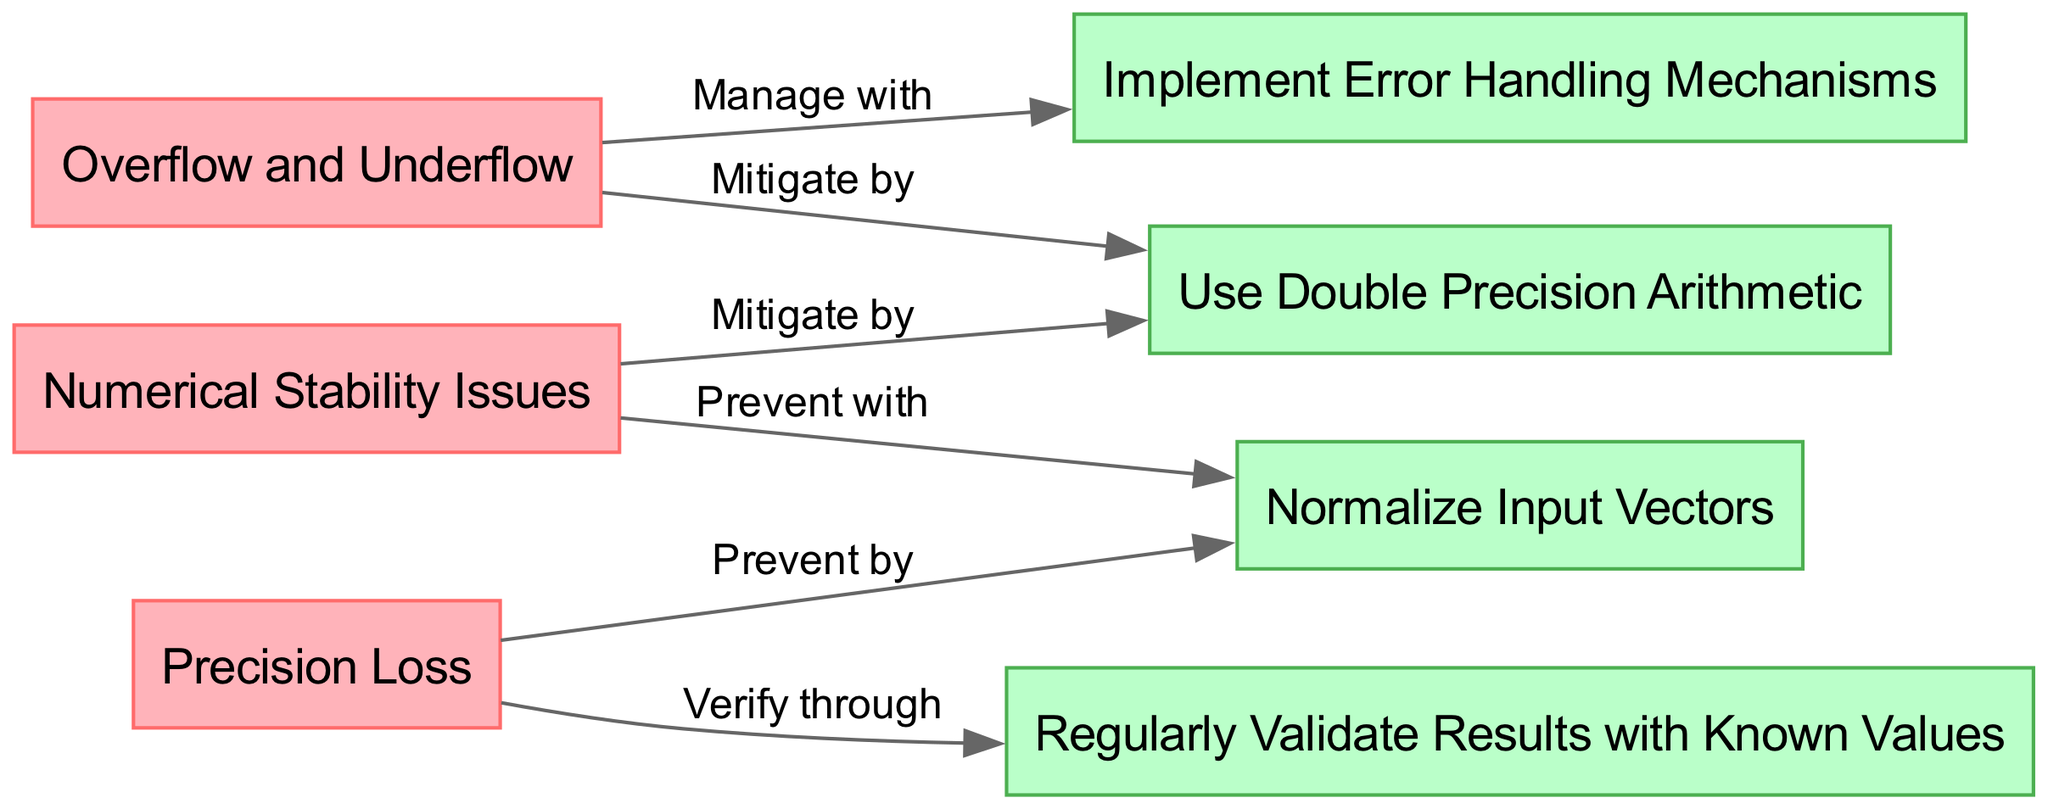What type of issues does "Numerical Stability Issues" refer to? "Numerical Stability Issues" is a node in the diagram that indicates a type of error faced during the implementation of the Hadamard Rule, relating specifically to difficulties in maintaining stable computations due to finite precision in digital arithmetic.
Answer: Numerical Stability Issues Which guideline is associated with "Overflow and Underflow"? In the diagram, "Overflow and Underflow" connects to "Use Double Precision Arithmetic" and "Implement Error Handling Mechanisms." The guideline specifically related to managing this error is "Implement Error Handling Mechanisms."
Answer: Implement Error Handling Mechanisms How many total errors are displayed in the diagram? The visual representation includes three error nodes: "Numerical Stability Issues," "Overflow and Underflow," and "Precision Loss." By counting these nodes, we determine that there are three errors.
Answer: Three What guideline is suggested to prevent "Precision Loss"? The diagram shows that "Precision Loss" can be prevented by using "Normalize Input Vectors." This connection indicates that normalizing input data is a recommended practice to mitigate this issue.
Answer: Normalize Input Vectors Which two guidelines are linked to "Numerical Stability Issues"? The connections illustrated in the diagram indicate that both "Use Double Precision Arithmetic" and "Normalize Input Vectors" are linked to "Numerical Stability Issues." By following these guidelines, one can manage the associated risks of this error.
Answer: Use Double Precision Arithmetic, Normalize Input Vectors How does one verify "Precision Loss" according to the diagram? The diagram indicates that "Precision Loss" can be verified through a guideline labeled "Regularly Validate Results with Known Values." This implies that consistently checking results against known benchmarks can help identify precision-related issues.
Answer: Regularly Validate Results with Known Values What is the relationship between "Overflow and Underflow" and "Use Double Precision Arithmetic"? In the diagram, "Overflow and Underflow" is mitigated by "Use Double Precision Arithmetic." This signifies that utilizing double precision can help reduce the risks associated with these types of mathematical errors.
Answer: Mitigated by How many guidelines are provided in the diagram? The diagram presents four guidelines regarding the management of errors encountered in the Hadamard Rule. By counting the unique guideline nodes, we find that there are four guidelines.
Answer: Four 